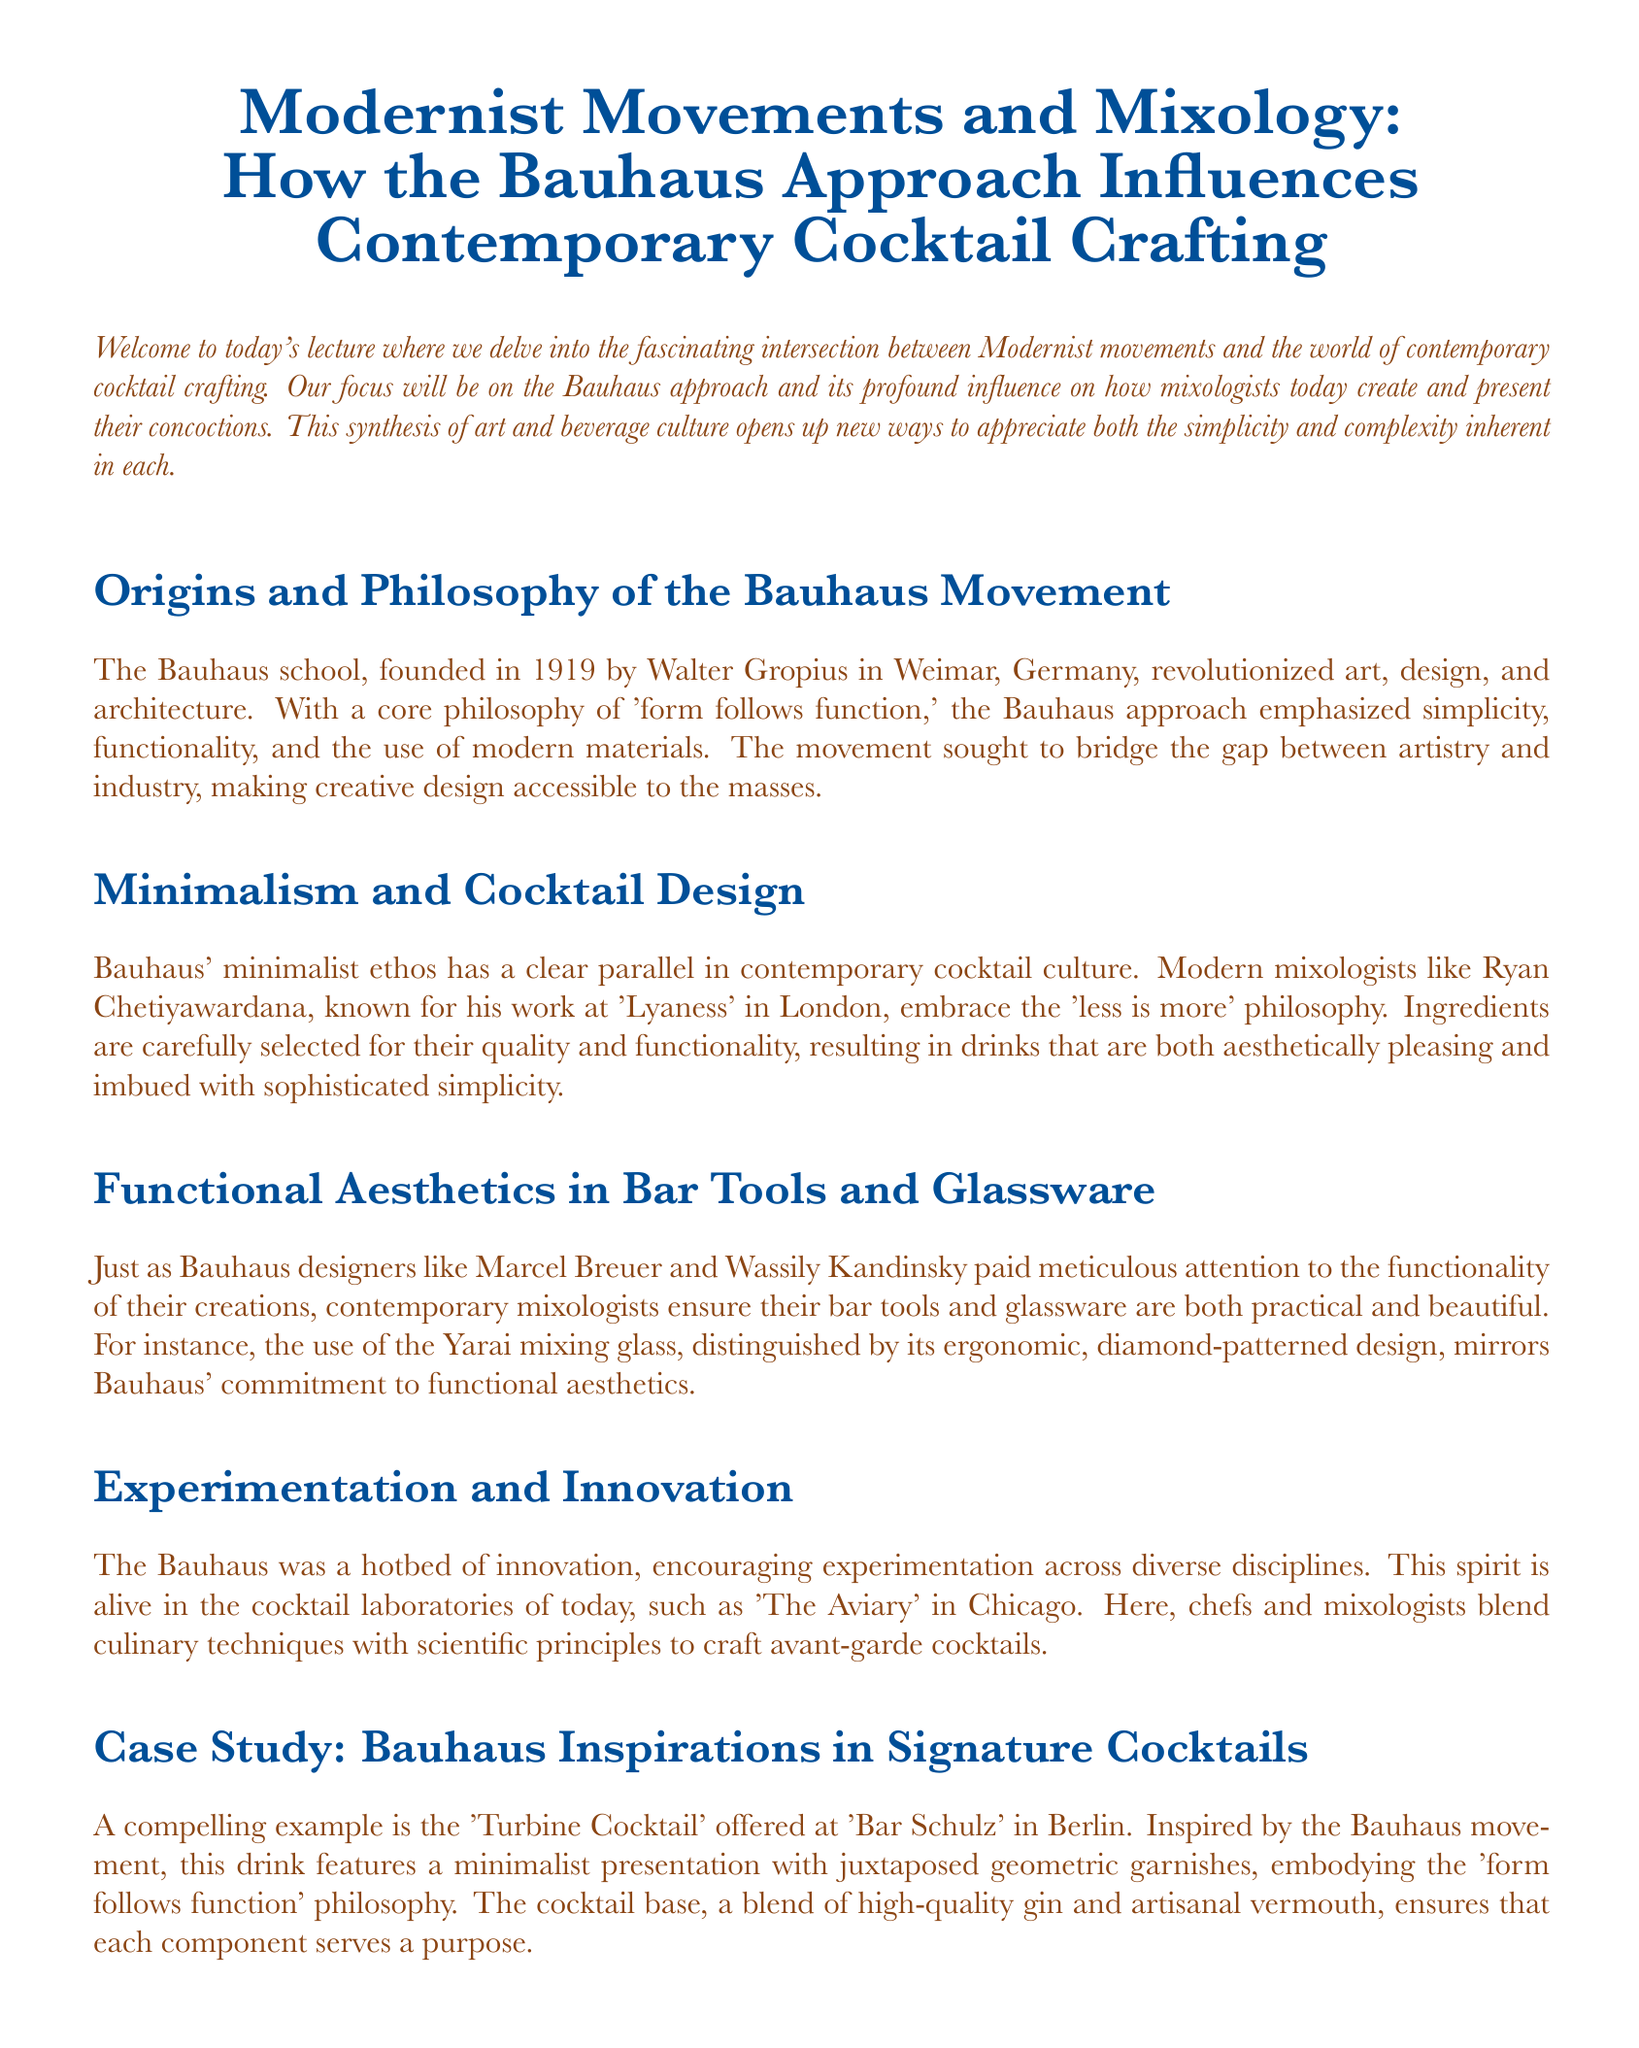What year was the Bauhaus founded? The document states that the Bauhaus was founded in 1919.
Answer: 1919 Who was the founder of the Bauhaus school? The document mentions Walter Gropius as the founder of the Bauhaus school.
Answer: Walter Gropius What is the core philosophy of the Bauhaus movement? The document explains that the core philosophy of the Bauhaus is 'form follows function.'
Answer: form follows function Which contemporary mixologist is known for the 'less is more' philosophy? The document identifies Ryan Chetiyawardana as a mixologist who embraces the 'less is more' philosophy.
Answer: Ryan Chetiyawardana What type of glass is mentioned as an example of functional aesthetics in bar tools? The document refers to the Yarai mixing glass as an example.
Answer: Yarai mixing glass Which cocktail is cited as being inspired by the Bauhaus movement? The 'Turbine Cocktail' at 'Bar Schulz' in Berlin is mentioned as inspired by the Bauhaus movement.
Answer: Turbine Cocktail Which cocktail laboratory is noted for its spirit of innovation? The document highlights 'The Aviary' in Chicago as a cocktail laboratory promoting innovation.
Answer: The Aviary What does the 'Turbine Cocktail' embody in terms of design philosophy? The document states that the Turbine Cocktail embodies the 'form follows function' philosophy.
Answer: form follows function What materials does the Bauhaus movement emphasize? The document mentions that the Bauhaus approach emphasizes the use of modern materials.
Answer: modern materials 